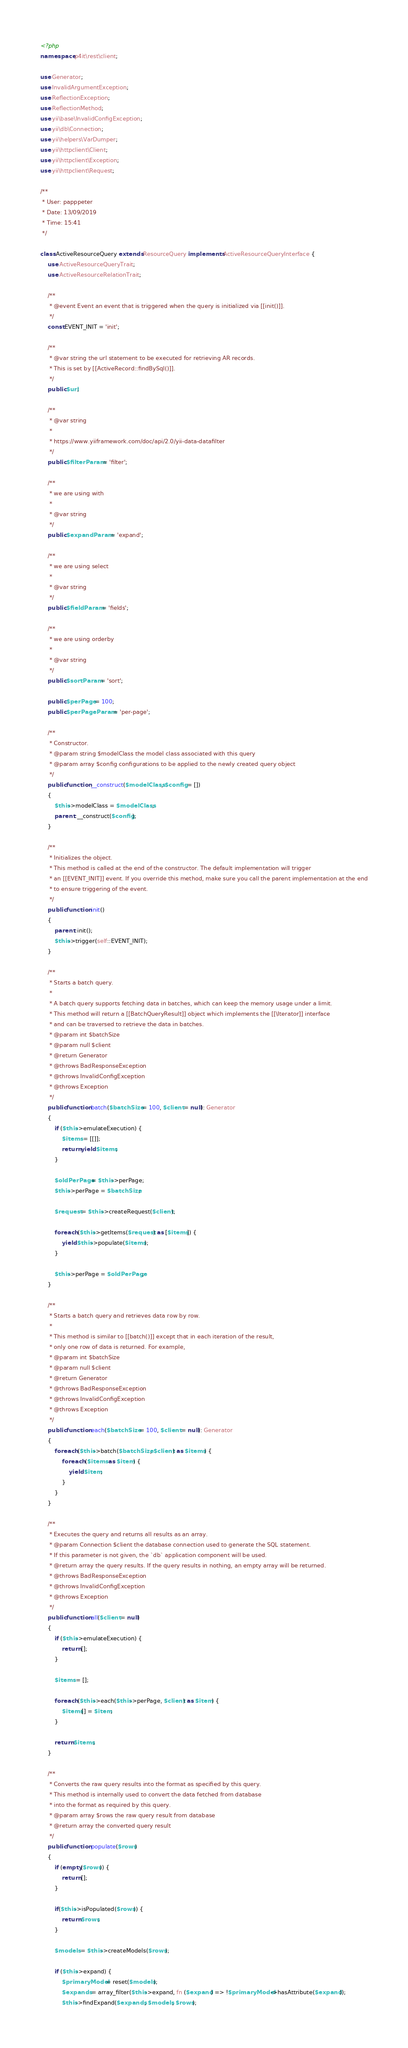<code> <loc_0><loc_0><loc_500><loc_500><_PHP_><?php
namespace p4it\rest\client;

use Generator;
use InvalidArgumentException;
use ReflectionException;
use ReflectionMethod;
use yii\base\InvalidConfigException;
use yii\db\Connection;
use yii\helpers\VarDumper;
use yii\httpclient\Client;
use yii\httpclient\Exception;
use yii\httpclient\Request;

/**
 * User: papppeter
 * Date: 13/09/2019
 * Time: 15:41
 */

class ActiveResourceQuery extends ResourceQuery implements ActiveResourceQueryInterface {
    use ActiveResourceQueryTrait;
    use ActiveResourceRelationTrait;

    /**
     * @event Event an event that is triggered when the query is initialized via [[init()]].
     */
    const EVENT_INIT = 'init';

    /**
     * @var string the url statement to be executed for retrieving AR records.
     * This is set by [[ActiveRecord::findBySql()]].
     */
    public $url;

    /**
     * @var string
     *
     * https://www.yiiframework.com/doc/api/2.0/yii-data-datafilter
     */
    public $filterParam = 'filter';

    /**
     * we are using with
     *
     * @var string
     */
    public $expandParam = 'expand';

    /**
     * we are using select
     *
     * @var string
     */
    public $fieldParam = 'fields';

    /**
     * we are using orderby
     *
     * @var string
     */
    public $sortParam = 'sort';

    public $perPage = 100;
    public $perPageParam = 'per-page';

    /**
     * Constructor.
     * @param string $modelClass the model class associated with this query
     * @param array $config configurations to be applied to the newly created query object
     */
    public function __construct($modelClass, $config = [])
    {
        $this->modelClass = $modelClass;
        parent::__construct($config);
    }

    /**
     * Initializes the object.
     * This method is called at the end of the constructor. The default implementation will trigger
     * an [[EVENT_INIT]] event. If you override this method, make sure you call the parent implementation at the end
     * to ensure triggering of the event.
     */
    public function init()
    {
        parent::init();
        $this->trigger(self::EVENT_INIT);
    }

    /**
     * Starts a batch query.
     *
     * A batch query supports fetching data in batches, which can keep the memory usage under a limit.
     * This method will return a [[BatchQueryResult]] object which implements the [[\Iterator]] interface
     * and can be traversed to retrieve the data in batches.
     * @param int $batchSize
     * @param null $client
     * @return Generator
     * @throws BadResponseException
     * @throws InvalidConfigException
     * @throws Exception
     */
    public function batch($batchSize = 100, $client = null): Generator
    {
        if ($this->emulateExecution) {
            $items = [[]];
            return yield $items;
        }

        $oldPerPage = $this->perPage;
        $this->perPage = $batchSize;

        $request = $this->createRequest($client);

        foreach ($this->getItems($request) as [$items]) {
            yield $this->populate($items);
        }

        $this->perPage = $oldPerPage;
    }

    /**
     * Starts a batch query and retrieves data row by row.
     *
     * This method is similar to [[batch()]] except that in each iteration of the result,
     * only one row of data is returned. For example,
     * @param int $batchSize
     * @param null $client
     * @return Generator
     * @throws BadResponseException
     * @throws InvalidConfigException
     * @throws Exception
     */
    public function each($batchSize = 100, $client = null): Generator
    {
        foreach ($this->batch($batchSize, $client) as $items) {
            foreach ($items as $item) {
                yield $item;
            }
        }
    }

    /**
     * Executes the query and returns all results as an array.
     * @param Connection $client the database connection used to generate the SQL statement.
     * If this parameter is not given, the `db` application component will be used.
     * @return array the query results. If the query results in nothing, an empty array will be returned.
     * @throws BadResponseException
     * @throws InvalidConfigException
     * @throws Exception
     */
    public function all($client = null)
    {
        if ($this->emulateExecution) {
            return [];
        }

        $items = [];

        foreach ($this->each($this->perPage, $client) as $item) {
            $items[] = $item;
        }

        return $items;
    }

    /**
     * Converts the raw query results into the format as specified by this query.
     * This method is internally used to convert the data fetched from database
     * into the format as required by this query.
     * @param array $rows the raw query result from database
     * @return array the converted query result
     */
    public function populate($rows)
    {
        if (empty($rows)) {
            return [];
        }

        if($this->isPopulated($rows)) {
            return $rows;
        }

        $models = $this->createModels($rows);

        if ($this->expand) {
            $primaryModel = reset($models);
            $expands = array_filter($this->expand, fn ($expand) => !$primaryModel->hasAttribute($expand));
            $this->findExpand($expands, $models, $rows);</code> 